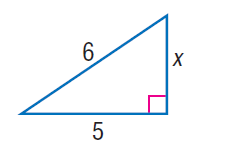Question: Find x.
Choices:
A. \sqrt { 7 }
B. \sqrt { 10 }
C. \sqrt { 11 }
D. \sqrt { 13 }
Answer with the letter. Answer: C 